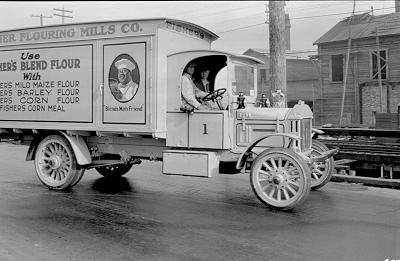How many people are riding in the truck?
Write a very short answer. 2. How many wheels does the truck have?
Give a very brief answer. 4. Is this photo from an old era?
Quick response, please. Yes. 